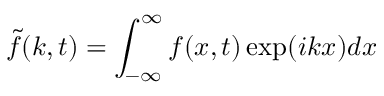<formula> <loc_0><loc_0><loc_500><loc_500>\tilde { f } ( k , t ) = \int _ { - \infty } ^ { \infty } f ( x , t ) \exp ( i k x ) d x</formula> 